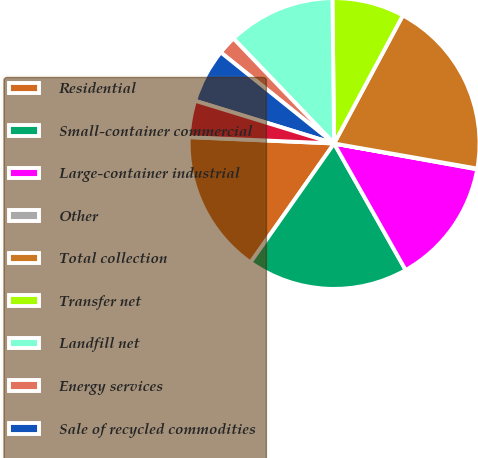<chart> <loc_0><loc_0><loc_500><loc_500><pie_chart><fcel>Residential<fcel>Small-container commercial<fcel>Large-container industrial<fcel>Other<fcel>Total collection<fcel>Transfer net<fcel>Landfill net<fcel>Energy services<fcel>Sale of recycled commodities<fcel>Other non-core<nl><fcel>15.95%<fcel>17.94%<fcel>13.97%<fcel>0.08%<fcel>19.92%<fcel>8.02%<fcel>11.98%<fcel>2.06%<fcel>6.03%<fcel>4.05%<nl></chart> 